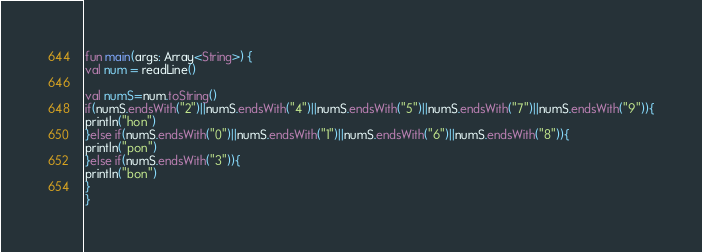<code> <loc_0><loc_0><loc_500><loc_500><_Kotlin_>fun main(args: Array<String>) {
val num = readLine()

val numS=num.toString()
if(numS.endsWith("2")||numS.endsWith("4")||numS.endsWith("5")||numS.endsWith("7")||numS.endsWith("9")){
println("hon")
}else if(numS.endsWith("0")||numS.endsWith("1")||numS.endsWith("6")||numS.endsWith("8")){
println("pon")
}else if(numS.endsWith("3")){
println("bon")
}
}</code> 